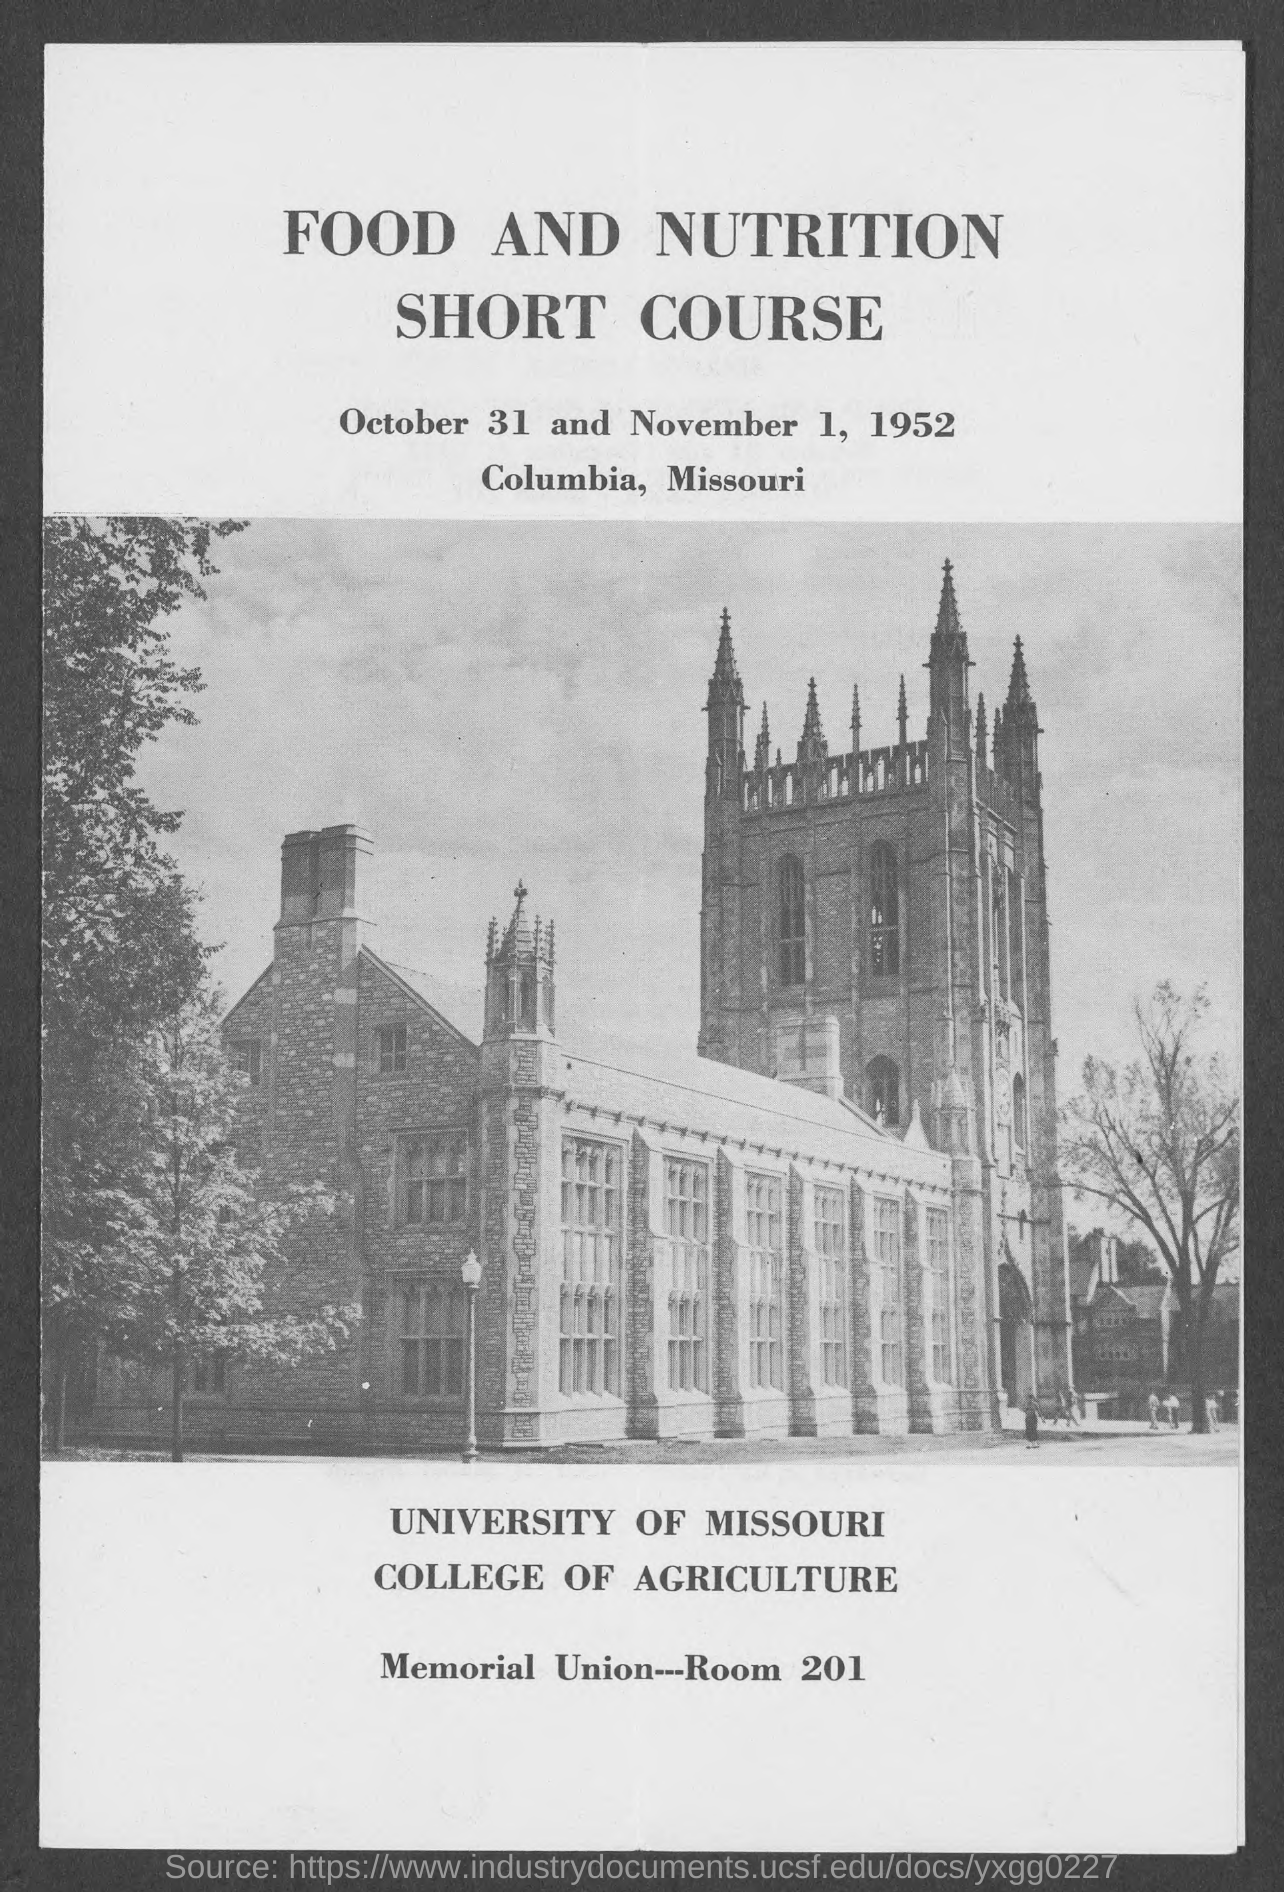Give some essential details in this illustration. The Memorial Union is located in ROOM 201. The course will take place on October 31 and November 1, 1952. The college of agriculture is mentioned. The University of Missouri is mentioned. The location of the course is Columbia. 